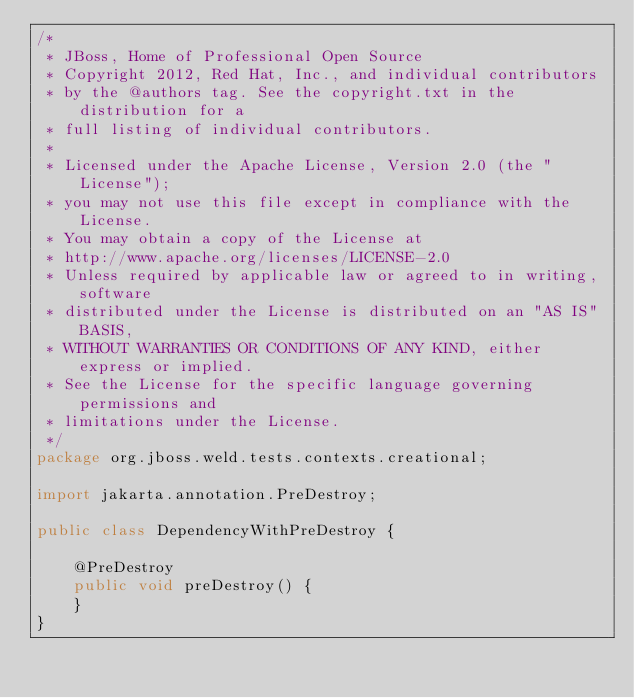Convert code to text. <code><loc_0><loc_0><loc_500><loc_500><_Java_>/*
 * JBoss, Home of Professional Open Source
 * Copyright 2012, Red Hat, Inc., and individual contributors
 * by the @authors tag. See the copyright.txt in the distribution for a
 * full listing of individual contributors.
 *
 * Licensed under the Apache License, Version 2.0 (the "License");
 * you may not use this file except in compliance with the License.
 * You may obtain a copy of the License at
 * http://www.apache.org/licenses/LICENSE-2.0
 * Unless required by applicable law or agreed to in writing, software
 * distributed under the License is distributed on an "AS IS" BASIS,
 * WITHOUT WARRANTIES OR CONDITIONS OF ANY KIND, either express or implied.
 * See the License for the specific language governing permissions and
 * limitations under the License.
 */
package org.jboss.weld.tests.contexts.creational;

import jakarta.annotation.PreDestroy;

public class DependencyWithPreDestroy {

    @PreDestroy
    public void preDestroy() {
    }
}
</code> 